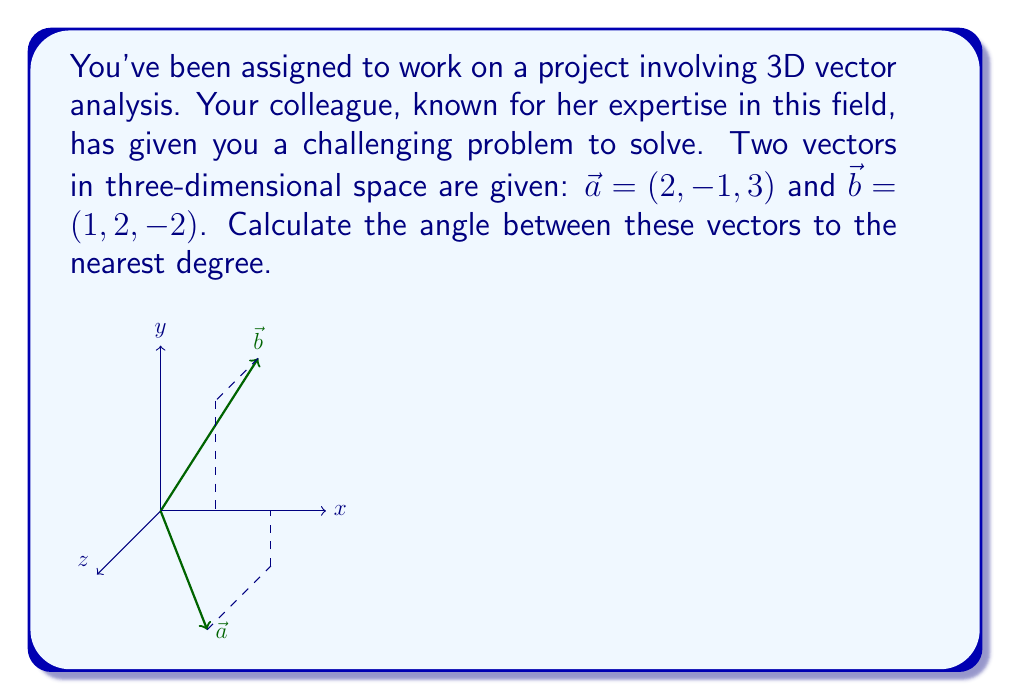Give your solution to this math problem. To find the angle between two vectors in three-dimensional space, we can use the dot product formula:

$$\cos \theta = \frac{\vec{a} \cdot \vec{b}}{|\vec{a}| |\vec{b}|}$$

Where $\theta$ is the angle between the vectors, $\vec{a} \cdot \vec{b}$ is the dot product of the vectors, and $|\vec{a}|$ and $|\vec{b}|$ are the magnitudes of the vectors.

Step 1: Calculate the dot product $\vec{a} \cdot \vec{b}$
$$\vec{a} \cdot \vec{b} = (2)(1) + (-1)(2) + (3)(-2) = 2 - 2 - 6 = -6$$

Step 2: Calculate the magnitudes of $\vec{a}$ and $\vec{b}$
$$|\vec{a}| = \sqrt{2^2 + (-1)^2 + 3^2} = \sqrt{4 + 1 + 9} = \sqrt{14}$$
$$|\vec{b}| = \sqrt{1^2 + 2^2 + (-2)^2} = \sqrt{1 + 4 + 4} = 3$$

Step 3: Substitute these values into the formula
$$\cos \theta = \frac{-6}{\sqrt{14} \cdot 3} = \frac{-6}{3\sqrt{14}}$$

Step 4: Take the inverse cosine (arccos) of both sides
$$\theta = \arccos(\frac{-6}{3\sqrt{14}}) \approx 2.4298 \text{ radians}$$

Step 5: Convert radians to degrees
$$\theta \approx 2.4298 \cdot \frac{180}{\pi} \approx 139.19°$$

Step 6: Round to the nearest degree
$$\theta \approx 139°$$
Answer: 139° 